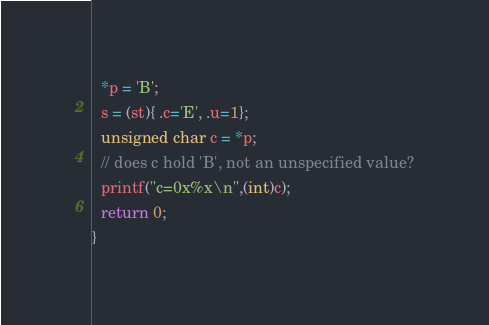<code> <loc_0><loc_0><loc_500><loc_500><_C_>  *p = 'B';
  s = (st){ .c='E', .u=1};
  unsigned char c = *p; 
  // does c hold 'B', not an unspecified value?
  printf("c=0x%x\n",(int)c);
  return 0;
}

</code> 